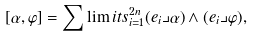<formula> <loc_0><loc_0><loc_500><loc_500>[ \alpha , \varphi ] = \sum \lim i t s _ { i = 1 } ^ { 2 n } ( e _ { i } \lrcorner \alpha ) \wedge ( e _ { i } \lrcorner \varphi ) ,</formula> 